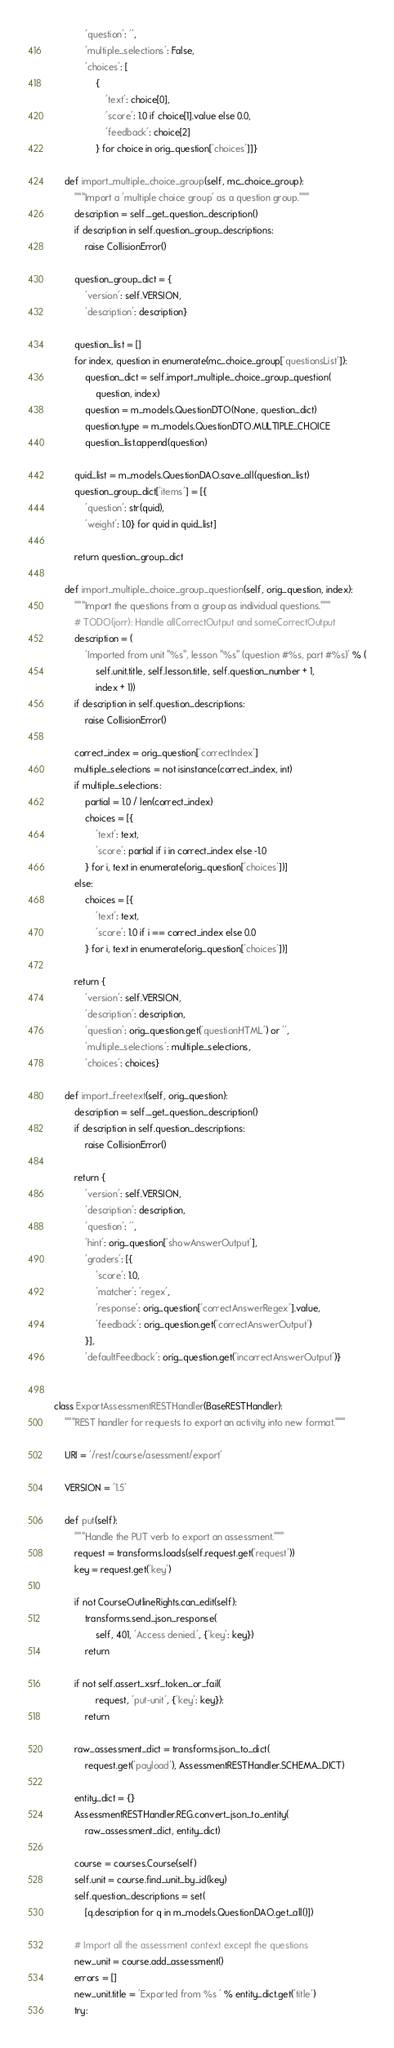Convert code to text. <code><loc_0><loc_0><loc_500><loc_500><_Python_>            'question': '',
            'multiple_selections': False,
            'choices': [
                {
                    'text': choice[0],
                    'score': 1.0 if choice[1].value else 0.0,
                    'feedback': choice[2]
                } for choice in orig_question['choices']]}

    def import_multiple_choice_group(self, mc_choice_group):
        """Import a 'multiple choice group' as a question group."""
        description = self._get_question_description()
        if description in self.question_group_descriptions:
            raise CollisionError()

        question_group_dict = {
            'version': self.VERSION,
            'description': description}

        question_list = []
        for index, question in enumerate(mc_choice_group['questionsList']):
            question_dict = self.import_multiple_choice_group_question(
                question, index)
            question = m_models.QuestionDTO(None, question_dict)
            question.type = m_models.QuestionDTO.MULTIPLE_CHOICE
            question_list.append(question)

        quid_list = m_models.QuestionDAO.save_all(question_list)
        question_group_dict['items'] = [{
            'question': str(quid),
            'weight': 1.0} for quid in quid_list]

        return question_group_dict

    def import_multiple_choice_group_question(self, orig_question, index):
        """Import the questions from a group as individual questions."""
        # TODO(jorr): Handle allCorrectOutput and someCorrectOutput
        description = (
            'Imported from unit "%s", lesson "%s" (question #%s, part #%s)' % (
                self.unit.title, self.lesson.title, self.question_number + 1,
                index + 1))
        if description in self.question_descriptions:
            raise CollisionError()

        correct_index = orig_question['correctIndex']
        multiple_selections = not isinstance(correct_index, int)
        if multiple_selections:
            partial = 1.0 / len(correct_index)
            choices = [{
                'text': text,
                'score': partial if i in correct_index else -1.0
            } for i, text in enumerate(orig_question['choices'])]
        else:
            choices = [{
                'text': text,
                'score': 1.0 if i == correct_index else 0.0
            } for i, text in enumerate(orig_question['choices'])]

        return {
            'version': self.VERSION,
            'description': description,
            'question': orig_question.get('questionHTML') or '',
            'multiple_selections': multiple_selections,
            'choices': choices}

    def import_freetext(self, orig_question):
        description = self._get_question_description()
        if description in self.question_descriptions:
            raise CollisionError()

        return {
            'version': self.VERSION,
            'description': description,
            'question': '',
            'hint': orig_question['showAnswerOutput'],
            'graders': [{
                'score': 1.0,
                'matcher': 'regex',
                'response': orig_question['correctAnswerRegex'].value,
                'feedback': orig_question.get('correctAnswerOutput')
            }],
            'defaultFeedback': orig_question.get('incorrectAnswerOutput')}


class ExportAssessmentRESTHandler(BaseRESTHandler):
    """REST handler for requests to export an activity into new format."""

    URI = '/rest/course/asessment/export'

    VERSION = '1.5'

    def put(self):
        """Handle the PUT verb to export an assessment."""
        request = transforms.loads(self.request.get('request'))
        key = request.get('key')

        if not CourseOutlineRights.can_edit(self):
            transforms.send_json_response(
                self, 401, 'Access denied.', {'key': key})
            return

        if not self.assert_xsrf_token_or_fail(
                request, 'put-unit', {'key': key}):
            return

        raw_assessment_dict = transforms.json_to_dict(
            request.get('payload'), AssessmentRESTHandler.SCHEMA_DICT)

        entity_dict = {}
        AssessmentRESTHandler.REG.convert_json_to_entity(
            raw_assessment_dict, entity_dict)

        course = courses.Course(self)
        self.unit = course.find_unit_by_id(key)
        self.question_descriptions = set(
            [q.description for q in m_models.QuestionDAO.get_all()])

        # Import all the assessment context except the questions
        new_unit = course.add_assessment()
        errors = []
        new_unit.title = 'Exported from %s ' % entity_dict.get('title')
        try:</code> 